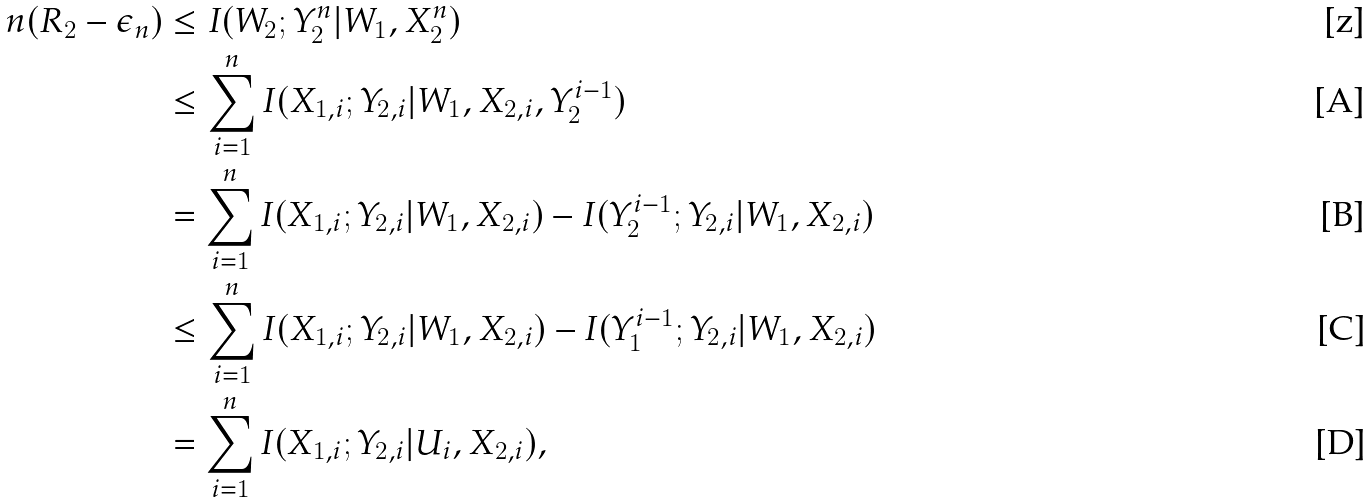<formula> <loc_0><loc_0><loc_500><loc_500>n ( R _ { 2 } - \epsilon _ { n } ) & \leq I ( W _ { 2 } ; Y _ { 2 } ^ { n } | W _ { 1 } , X _ { 2 } ^ { n } ) \\ & \leq \sum _ { i = 1 } ^ { n } I ( X _ { 1 , i } ; Y _ { 2 , i } | W _ { 1 } , X _ { 2 , i } , Y _ { 2 } ^ { i - 1 } ) \\ & = \sum _ { i = 1 } ^ { n } I ( X _ { 1 , i } ; Y _ { 2 , i } | W _ { 1 } , X _ { 2 , i } ) - I ( Y _ { 2 } ^ { i - 1 } ; Y _ { 2 , i } | W _ { 1 } , X _ { 2 , i } ) \\ & \leq \sum _ { i = 1 } ^ { n } I ( X _ { 1 , i } ; Y _ { 2 , i } | W _ { 1 } , X _ { 2 , i } ) - I ( Y _ { 1 } ^ { i - 1 } ; Y _ { 2 , i } | W _ { 1 } , X _ { 2 , i } ) \\ & = \sum _ { i = 1 } ^ { n } I ( X _ { 1 , i } ; Y _ { 2 , i } | U _ { i } , X _ { 2 , i } ) ,</formula> 